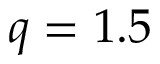<formula> <loc_0><loc_0><loc_500><loc_500>q = 1 . 5</formula> 